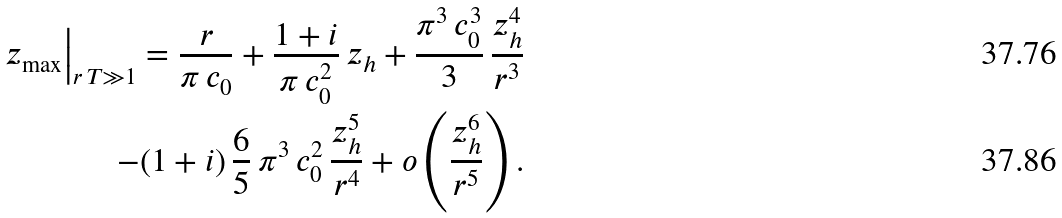<formula> <loc_0><loc_0><loc_500><loc_500>z _ { \max } \Big | _ { r \, T \gg 1 } = \frac { r } { \pi \, c _ { 0 } } + \frac { 1 + i } { \pi \, c _ { 0 } ^ { 2 } } \, z _ { h } + \frac { \pi ^ { 3 } \, c _ { 0 } ^ { 3 } } { 3 } \, \frac { z _ { h } ^ { 4 } } { r ^ { 3 } } \\ - ( 1 + i ) \, \frac { 6 } { 5 } \, \pi ^ { 3 } \, c _ { 0 } ^ { 2 } \, \frac { z _ { h } ^ { 5 } } { r ^ { 4 } } + o \left ( \frac { z _ { h } ^ { 6 } } { r ^ { 5 } } \right ) .</formula> 